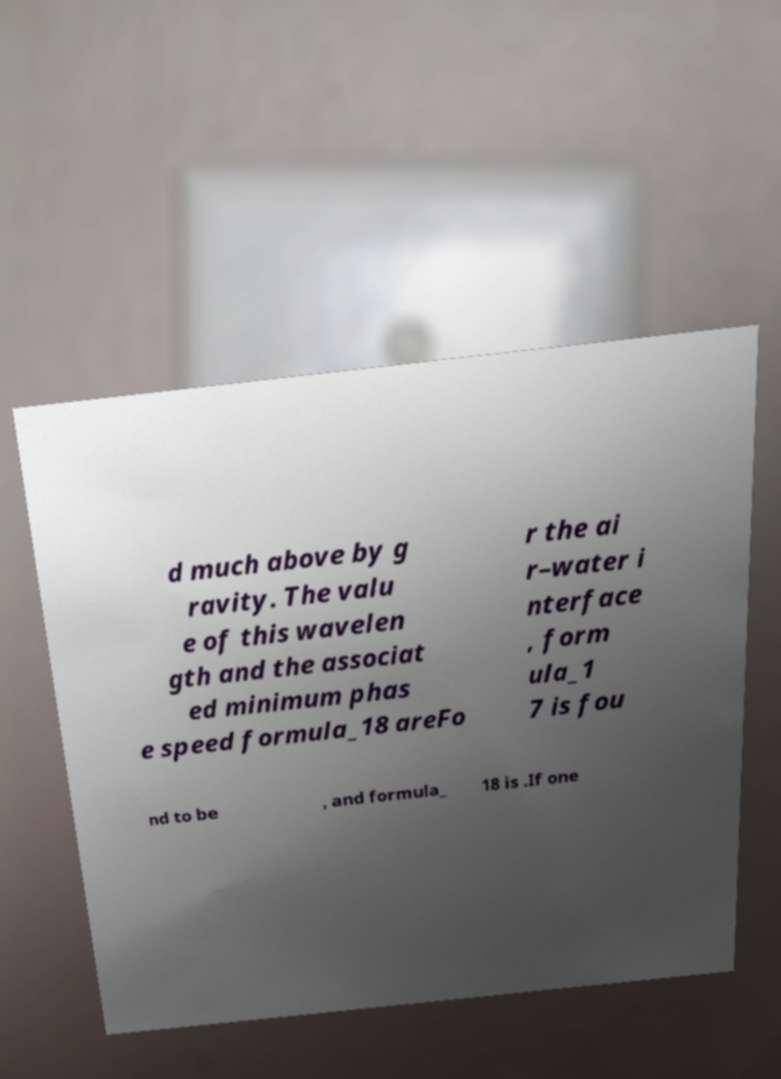There's text embedded in this image that I need extracted. Can you transcribe it verbatim? d much above by g ravity. The valu e of this wavelen gth and the associat ed minimum phas e speed formula_18 areFo r the ai r–water i nterface , form ula_1 7 is fou nd to be , and formula_ 18 is .If one 